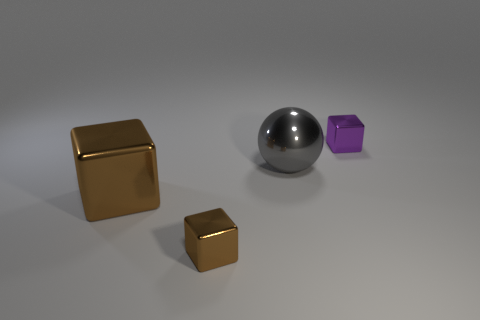What number of other things are the same material as the big brown thing?
Your response must be concise. 3. Is the shape of the tiny thing on the left side of the tiny purple cube the same as  the large gray object?
Provide a short and direct response. No. What number of things are either big blue shiny things or gray metallic spheres?
Give a very brief answer. 1. What size is the block that is on the right side of the tiny block on the left side of the purple metallic cube?
Provide a short and direct response. Small. What number of metallic cubes are on the left side of the ball and behind the large gray thing?
Your answer should be very brief. 0. There is a brown metal thing that is right of the large shiny object that is left of the gray metal sphere; are there any tiny blocks right of it?
Provide a succinct answer. Yes. The object that is the same size as the purple cube is what shape?
Give a very brief answer. Cube. Are there any shiny objects of the same color as the big shiny block?
Your answer should be compact. Yes. Is the shape of the large brown metal object the same as the tiny brown object?
Give a very brief answer. Yes. What number of big objects are either green blocks or gray metallic spheres?
Provide a short and direct response. 1. 